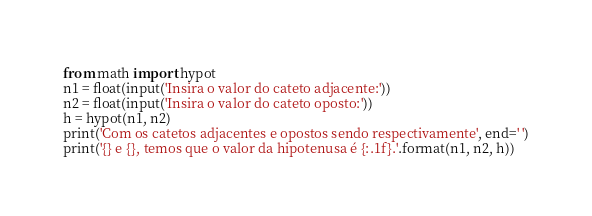<code> <loc_0><loc_0><loc_500><loc_500><_Python_>from math import hypot
n1 = float(input('Insira o valor do cateto adjacente:'))
n2 = float(input('Insira o valor do cateto oposto:'))
h = hypot(n1, n2)
print('Com os catetos adjacentes e opostos sendo respectivamente', end=' ')
print('{} e {}, temos que o valor da hipotenusa é {:.1f}.'.format(n1, n2, h))


</code> 